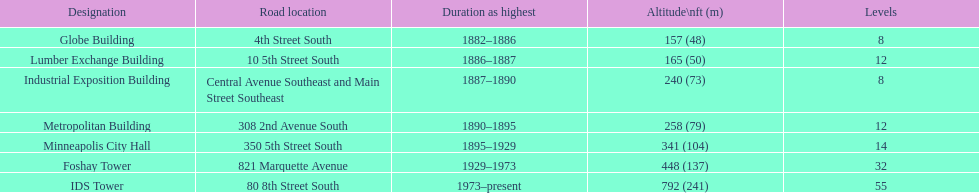How tall is it to the top of the ids tower in feet? 792. 